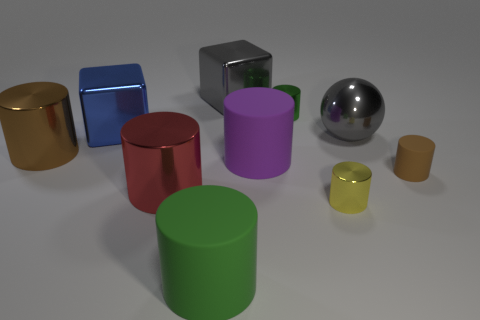Subtract 4 cylinders. How many cylinders are left? 3 Subtract all large red cylinders. How many cylinders are left? 6 Subtract all yellow cylinders. How many cylinders are left? 6 Subtract all gray cylinders. Subtract all red balls. How many cylinders are left? 7 Subtract all cubes. How many objects are left? 8 Add 1 green things. How many green things exist? 3 Subtract 0 brown spheres. How many objects are left? 10 Subtract all gray shiny things. Subtract all brown matte things. How many objects are left? 7 Add 7 purple things. How many purple things are left? 8 